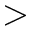<formula> <loc_0><loc_0><loc_500><loc_500>></formula> 